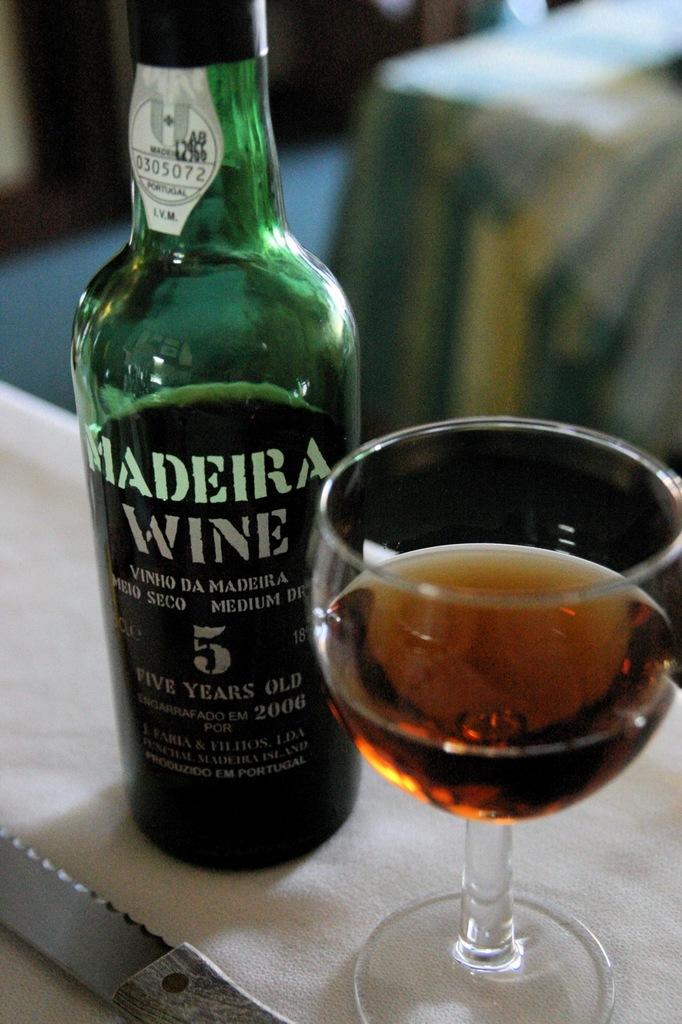How old is the wine?
Ensure brevity in your answer.  5 years old. 